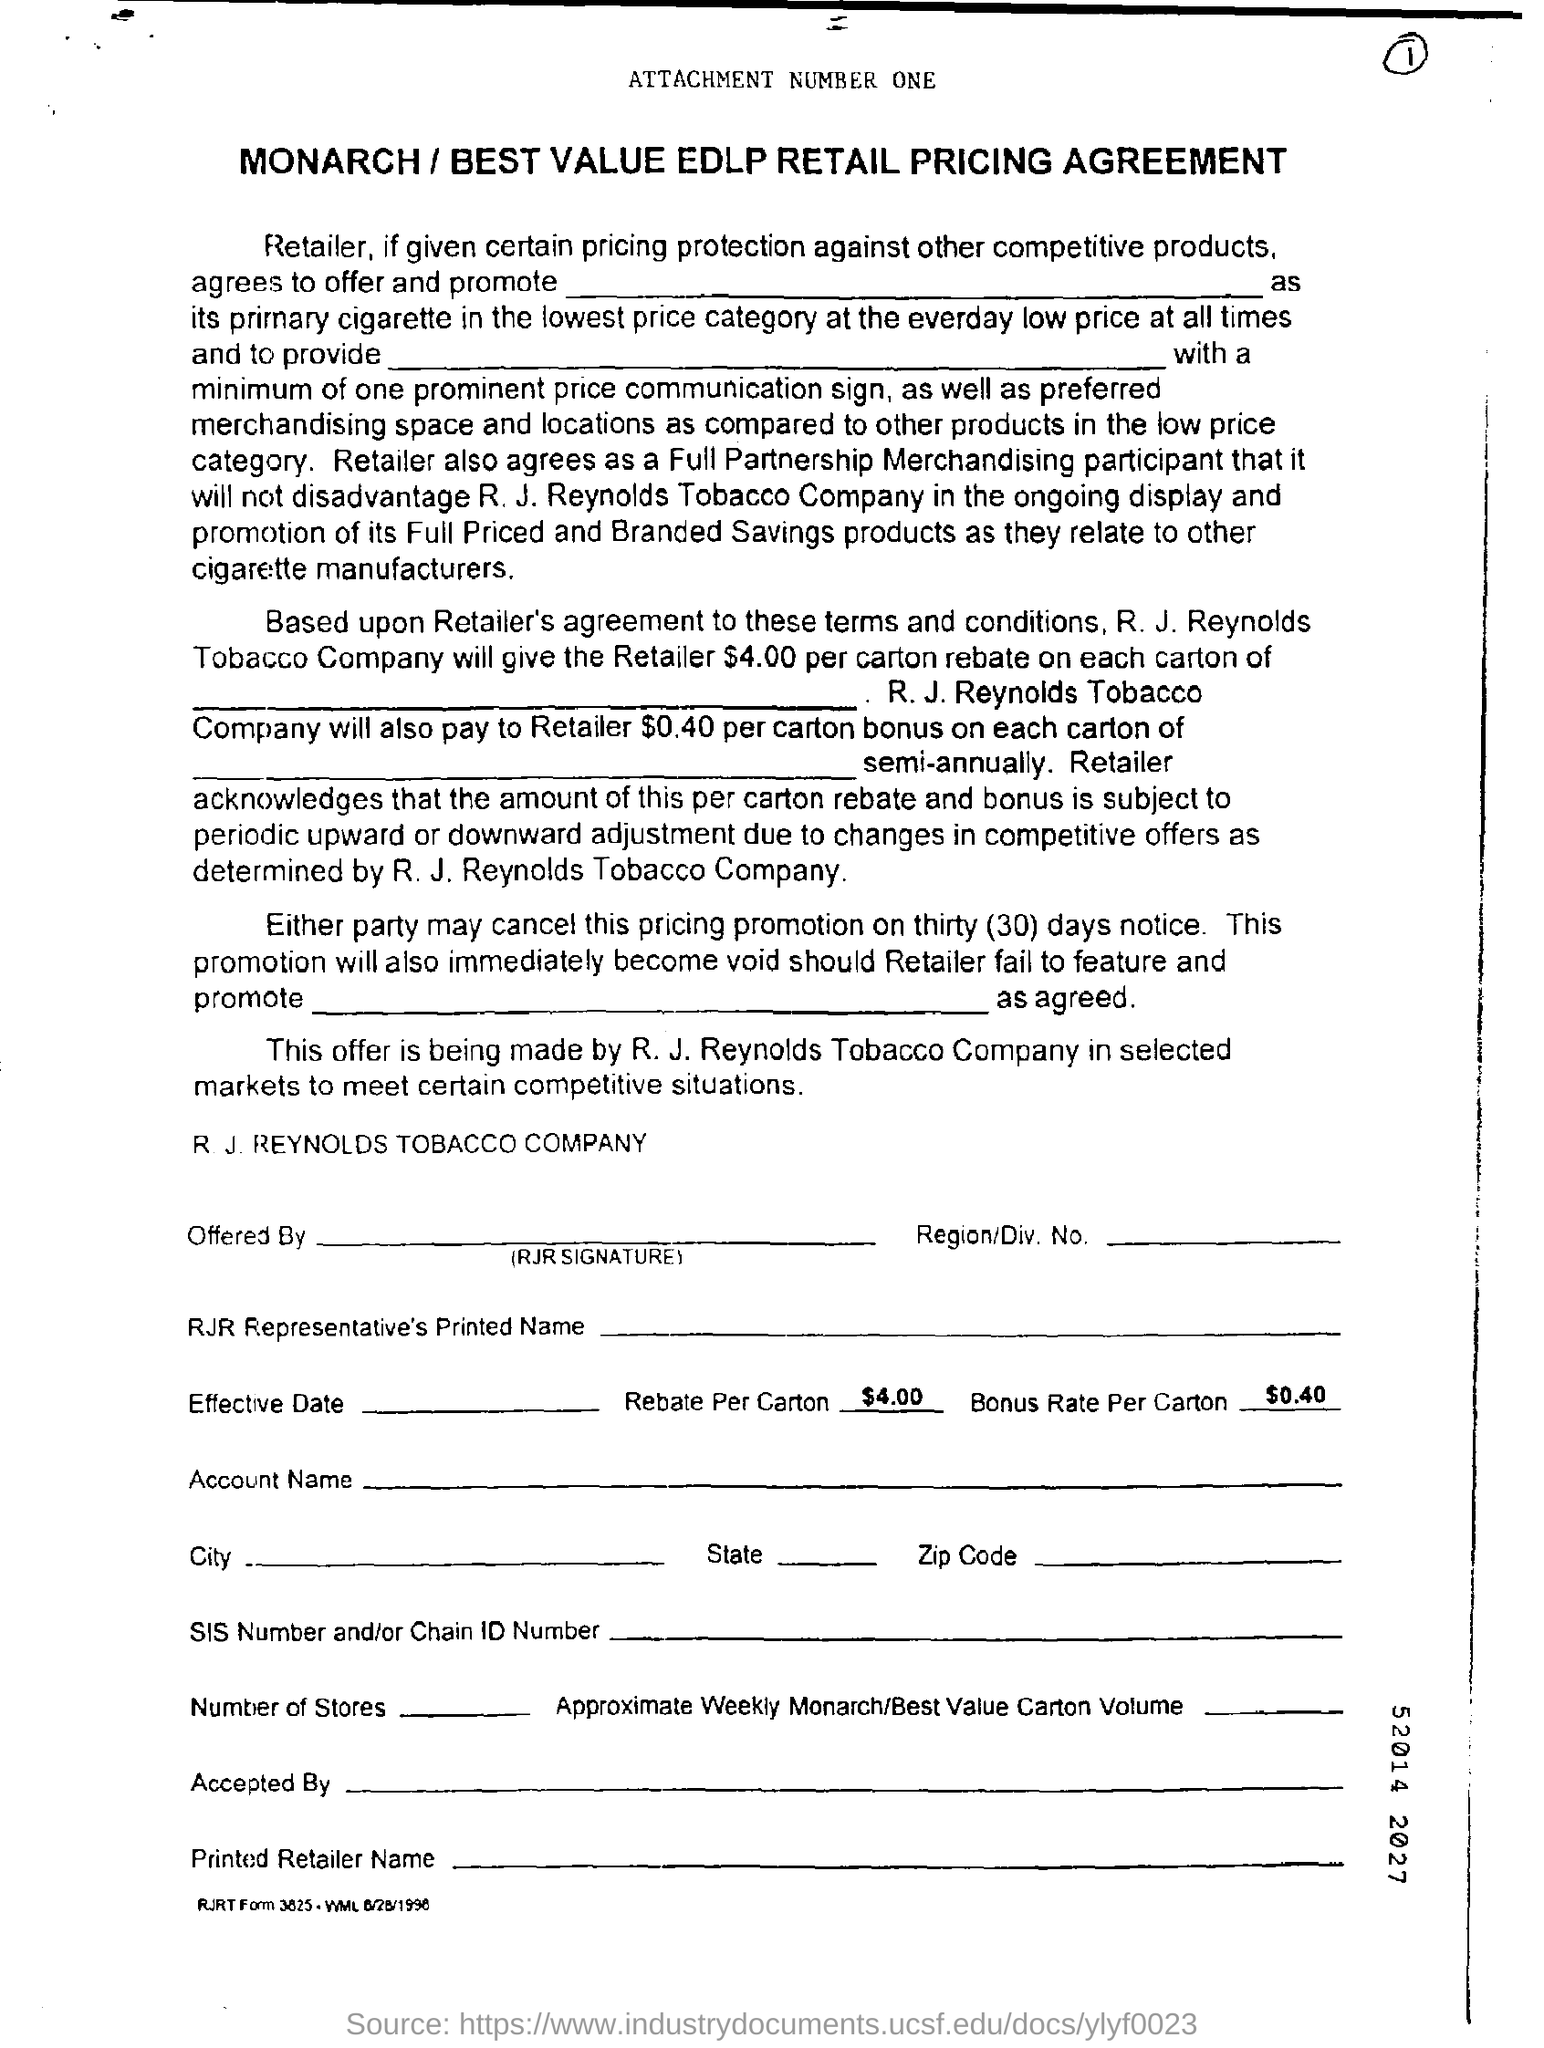How much is Rebate Per Carton?
Your answer should be compact. $4.00 per carton. How much is Bonus Rate Per Carton ?
Offer a very short reply. $0.40 per carton. What is the notice period for the cancellation of pricing promotion ?
Provide a succinct answer. Thirty (30) days. 